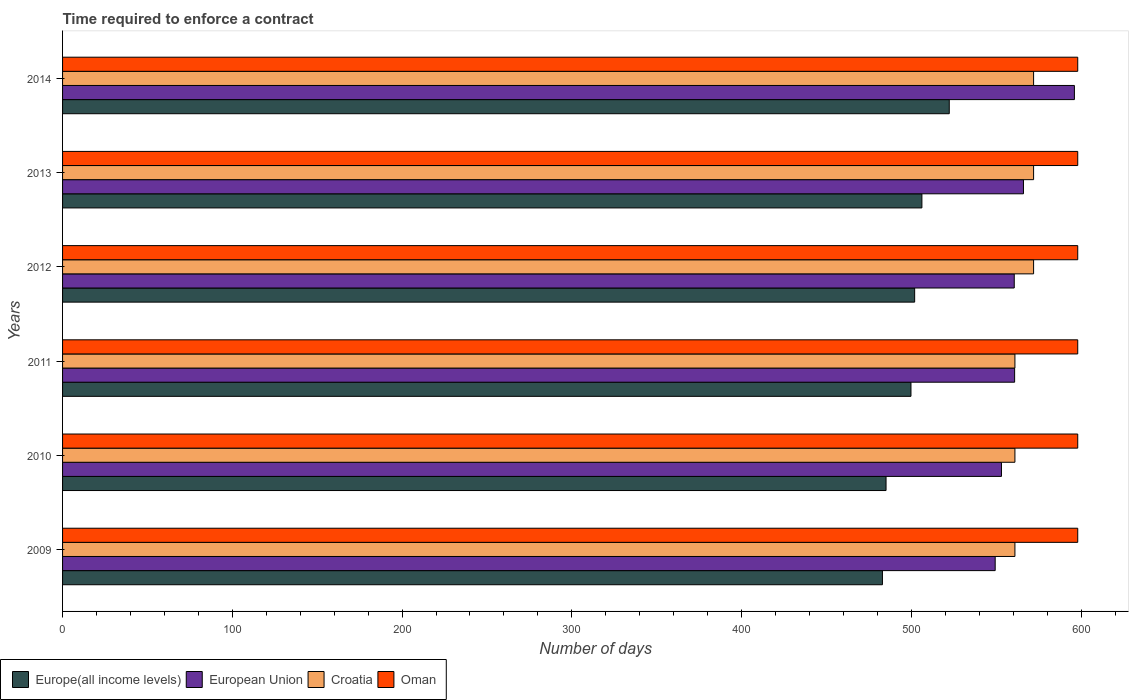How many bars are there on the 1st tick from the bottom?
Provide a succinct answer. 4. What is the label of the 1st group of bars from the top?
Make the answer very short. 2014. In how many cases, is the number of bars for a given year not equal to the number of legend labels?
Provide a short and direct response. 0. What is the number of days required to enforce a contract in Oman in 2011?
Keep it short and to the point. 598. Across all years, what is the maximum number of days required to enforce a contract in Croatia?
Offer a terse response. 572. Across all years, what is the minimum number of days required to enforce a contract in European Union?
Ensure brevity in your answer.  549.37. In which year was the number of days required to enforce a contract in Oman maximum?
Provide a short and direct response. 2009. In which year was the number of days required to enforce a contract in European Union minimum?
Ensure brevity in your answer.  2009. What is the total number of days required to enforce a contract in European Union in the graph?
Make the answer very short. 3385.94. What is the difference between the number of days required to enforce a contract in Oman in 2012 and that in 2013?
Give a very brief answer. 0. What is the difference between the number of days required to enforce a contract in Oman in 2009 and the number of days required to enforce a contract in Europe(all income levels) in 2013?
Give a very brief answer. 91.8. What is the average number of days required to enforce a contract in European Union per year?
Your answer should be compact. 564.32. In the year 2010, what is the difference between the number of days required to enforce a contract in Oman and number of days required to enforce a contract in Europe(all income levels)?
Your answer should be compact. 112.91. What is the ratio of the number of days required to enforce a contract in Europe(all income levels) in 2009 to that in 2011?
Your response must be concise. 0.97. Is the number of days required to enforce a contract in Europe(all income levels) in 2009 less than that in 2014?
Your answer should be very brief. Yes. What is the difference between the highest and the second highest number of days required to enforce a contract in European Union?
Your answer should be compact. 30. What is the difference between the highest and the lowest number of days required to enforce a contract in European Union?
Your response must be concise. 46.67. Is the sum of the number of days required to enforce a contract in Oman in 2011 and 2014 greater than the maximum number of days required to enforce a contract in Europe(all income levels) across all years?
Your response must be concise. Yes. Is it the case that in every year, the sum of the number of days required to enforce a contract in Croatia and number of days required to enforce a contract in European Union is greater than the sum of number of days required to enforce a contract in Europe(all income levels) and number of days required to enforce a contract in Oman?
Keep it short and to the point. Yes. What does the 1st bar from the top in 2010 represents?
Provide a succinct answer. Oman. What does the 1st bar from the bottom in 2012 represents?
Keep it short and to the point. Europe(all income levels). Is it the case that in every year, the sum of the number of days required to enforce a contract in Oman and number of days required to enforce a contract in European Union is greater than the number of days required to enforce a contract in Europe(all income levels)?
Make the answer very short. Yes. Are all the bars in the graph horizontal?
Provide a succinct answer. Yes. What is the difference between two consecutive major ticks on the X-axis?
Your response must be concise. 100. Are the values on the major ticks of X-axis written in scientific E-notation?
Ensure brevity in your answer.  No. Where does the legend appear in the graph?
Keep it short and to the point. Bottom left. How many legend labels are there?
Provide a succinct answer. 4. How are the legend labels stacked?
Offer a very short reply. Horizontal. What is the title of the graph?
Provide a succinct answer. Time required to enforce a contract. Does "France" appear as one of the legend labels in the graph?
Offer a very short reply. No. What is the label or title of the X-axis?
Provide a succinct answer. Number of days. What is the Number of days in Europe(all income levels) in 2009?
Your response must be concise. 482.96. What is the Number of days in European Union in 2009?
Offer a very short reply. 549.37. What is the Number of days in Croatia in 2009?
Your response must be concise. 561. What is the Number of days in Oman in 2009?
Give a very brief answer. 598. What is the Number of days of Europe(all income levels) in 2010?
Keep it short and to the point. 485.09. What is the Number of days in European Union in 2010?
Ensure brevity in your answer.  553.07. What is the Number of days of Croatia in 2010?
Provide a succinct answer. 561. What is the Number of days of Oman in 2010?
Keep it short and to the point. 598. What is the Number of days in Europe(all income levels) in 2011?
Provide a short and direct response. 499.77. What is the Number of days in European Union in 2011?
Make the answer very short. 560.82. What is the Number of days in Croatia in 2011?
Your answer should be compact. 561. What is the Number of days of Oman in 2011?
Give a very brief answer. 598. What is the Number of days in Europe(all income levels) in 2012?
Offer a very short reply. 501.94. What is the Number of days in European Union in 2012?
Offer a very short reply. 560.61. What is the Number of days of Croatia in 2012?
Make the answer very short. 572. What is the Number of days in Oman in 2012?
Your answer should be compact. 598. What is the Number of days in Europe(all income levels) in 2013?
Your answer should be very brief. 506.2. What is the Number of days of European Union in 2013?
Provide a short and direct response. 566.04. What is the Number of days in Croatia in 2013?
Keep it short and to the point. 572. What is the Number of days of Oman in 2013?
Give a very brief answer. 598. What is the Number of days in Europe(all income levels) in 2014?
Provide a short and direct response. 522.33. What is the Number of days of European Union in 2014?
Ensure brevity in your answer.  596.04. What is the Number of days in Croatia in 2014?
Provide a succinct answer. 572. What is the Number of days of Oman in 2014?
Offer a terse response. 598. Across all years, what is the maximum Number of days in Europe(all income levels)?
Give a very brief answer. 522.33. Across all years, what is the maximum Number of days of European Union?
Provide a succinct answer. 596.04. Across all years, what is the maximum Number of days in Croatia?
Make the answer very short. 572. Across all years, what is the maximum Number of days of Oman?
Keep it short and to the point. 598. Across all years, what is the minimum Number of days in Europe(all income levels)?
Provide a short and direct response. 482.96. Across all years, what is the minimum Number of days of European Union?
Offer a terse response. 549.37. Across all years, what is the minimum Number of days of Croatia?
Offer a terse response. 561. Across all years, what is the minimum Number of days of Oman?
Provide a short and direct response. 598. What is the total Number of days in Europe(all income levels) in the graph?
Your answer should be compact. 2998.28. What is the total Number of days of European Union in the graph?
Keep it short and to the point. 3385.94. What is the total Number of days of Croatia in the graph?
Ensure brevity in your answer.  3399. What is the total Number of days of Oman in the graph?
Keep it short and to the point. 3588. What is the difference between the Number of days in Europe(all income levels) in 2009 and that in 2010?
Provide a short and direct response. -2.13. What is the difference between the Number of days of European Union in 2009 and that in 2010?
Offer a very short reply. -3.7. What is the difference between the Number of days in Croatia in 2009 and that in 2010?
Make the answer very short. 0. What is the difference between the Number of days of Europe(all income levels) in 2009 and that in 2011?
Your response must be concise. -16.81. What is the difference between the Number of days of European Union in 2009 and that in 2011?
Offer a terse response. -11.45. What is the difference between the Number of days of Croatia in 2009 and that in 2011?
Provide a short and direct response. 0. What is the difference between the Number of days of Europe(all income levels) in 2009 and that in 2012?
Your answer should be very brief. -18.98. What is the difference between the Number of days of European Union in 2009 and that in 2012?
Make the answer very short. -11.24. What is the difference between the Number of days of Croatia in 2009 and that in 2012?
Ensure brevity in your answer.  -11. What is the difference between the Number of days of Oman in 2009 and that in 2012?
Ensure brevity in your answer.  0. What is the difference between the Number of days in Europe(all income levels) in 2009 and that in 2013?
Provide a short and direct response. -23.25. What is the difference between the Number of days of European Union in 2009 and that in 2013?
Keep it short and to the point. -16.67. What is the difference between the Number of days of Europe(all income levels) in 2009 and that in 2014?
Your response must be concise. -39.37. What is the difference between the Number of days of European Union in 2009 and that in 2014?
Keep it short and to the point. -46.67. What is the difference between the Number of days of Oman in 2009 and that in 2014?
Give a very brief answer. 0. What is the difference between the Number of days of Europe(all income levels) in 2010 and that in 2011?
Offer a very short reply. -14.68. What is the difference between the Number of days of European Union in 2010 and that in 2011?
Give a very brief answer. -7.75. What is the difference between the Number of days in Oman in 2010 and that in 2011?
Your answer should be compact. 0. What is the difference between the Number of days of Europe(all income levels) in 2010 and that in 2012?
Ensure brevity in your answer.  -16.85. What is the difference between the Number of days in European Union in 2010 and that in 2012?
Ensure brevity in your answer.  -7.53. What is the difference between the Number of days of Europe(all income levels) in 2010 and that in 2013?
Give a very brief answer. -21.12. What is the difference between the Number of days of European Union in 2010 and that in 2013?
Make the answer very short. -12.96. What is the difference between the Number of days of Europe(all income levels) in 2010 and that in 2014?
Your answer should be very brief. -37.24. What is the difference between the Number of days of European Union in 2010 and that in 2014?
Your answer should be very brief. -42.96. What is the difference between the Number of days of Croatia in 2010 and that in 2014?
Provide a short and direct response. -11. What is the difference between the Number of days of Europe(all income levels) in 2011 and that in 2012?
Your answer should be compact. -2.17. What is the difference between the Number of days of European Union in 2011 and that in 2012?
Provide a succinct answer. 0.21. What is the difference between the Number of days in Croatia in 2011 and that in 2012?
Your answer should be very brief. -11. What is the difference between the Number of days in Oman in 2011 and that in 2012?
Give a very brief answer. 0. What is the difference between the Number of days in Europe(all income levels) in 2011 and that in 2013?
Ensure brevity in your answer.  -6.44. What is the difference between the Number of days in European Union in 2011 and that in 2013?
Give a very brief answer. -5.21. What is the difference between the Number of days of Croatia in 2011 and that in 2013?
Your answer should be compact. -11. What is the difference between the Number of days of Oman in 2011 and that in 2013?
Your answer should be very brief. 0. What is the difference between the Number of days in Europe(all income levels) in 2011 and that in 2014?
Provide a short and direct response. -22.56. What is the difference between the Number of days of European Union in 2011 and that in 2014?
Your answer should be very brief. -35.21. What is the difference between the Number of days in Oman in 2011 and that in 2014?
Ensure brevity in your answer.  0. What is the difference between the Number of days of Europe(all income levels) in 2012 and that in 2013?
Offer a very short reply. -4.27. What is the difference between the Number of days of European Union in 2012 and that in 2013?
Give a very brief answer. -5.43. What is the difference between the Number of days of Croatia in 2012 and that in 2013?
Provide a short and direct response. 0. What is the difference between the Number of days in Europe(all income levels) in 2012 and that in 2014?
Offer a terse response. -20.39. What is the difference between the Number of days in European Union in 2012 and that in 2014?
Ensure brevity in your answer.  -35.43. What is the difference between the Number of days of Europe(all income levels) in 2013 and that in 2014?
Make the answer very short. -16.12. What is the difference between the Number of days of Croatia in 2013 and that in 2014?
Keep it short and to the point. 0. What is the difference between the Number of days in Oman in 2013 and that in 2014?
Your answer should be compact. 0. What is the difference between the Number of days of Europe(all income levels) in 2009 and the Number of days of European Union in 2010?
Provide a succinct answer. -70.12. What is the difference between the Number of days in Europe(all income levels) in 2009 and the Number of days in Croatia in 2010?
Offer a very short reply. -78.04. What is the difference between the Number of days in Europe(all income levels) in 2009 and the Number of days in Oman in 2010?
Give a very brief answer. -115.04. What is the difference between the Number of days of European Union in 2009 and the Number of days of Croatia in 2010?
Offer a terse response. -11.63. What is the difference between the Number of days in European Union in 2009 and the Number of days in Oman in 2010?
Keep it short and to the point. -48.63. What is the difference between the Number of days in Croatia in 2009 and the Number of days in Oman in 2010?
Provide a short and direct response. -37. What is the difference between the Number of days in Europe(all income levels) in 2009 and the Number of days in European Union in 2011?
Provide a short and direct response. -77.86. What is the difference between the Number of days of Europe(all income levels) in 2009 and the Number of days of Croatia in 2011?
Provide a short and direct response. -78.04. What is the difference between the Number of days of Europe(all income levels) in 2009 and the Number of days of Oman in 2011?
Your response must be concise. -115.04. What is the difference between the Number of days of European Union in 2009 and the Number of days of Croatia in 2011?
Offer a terse response. -11.63. What is the difference between the Number of days in European Union in 2009 and the Number of days in Oman in 2011?
Provide a short and direct response. -48.63. What is the difference between the Number of days of Croatia in 2009 and the Number of days of Oman in 2011?
Your response must be concise. -37. What is the difference between the Number of days of Europe(all income levels) in 2009 and the Number of days of European Union in 2012?
Provide a short and direct response. -77.65. What is the difference between the Number of days of Europe(all income levels) in 2009 and the Number of days of Croatia in 2012?
Keep it short and to the point. -89.04. What is the difference between the Number of days of Europe(all income levels) in 2009 and the Number of days of Oman in 2012?
Your answer should be very brief. -115.04. What is the difference between the Number of days in European Union in 2009 and the Number of days in Croatia in 2012?
Offer a very short reply. -22.63. What is the difference between the Number of days of European Union in 2009 and the Number of days of Oman in 2012?
Your response must be concise. -48.63. What is the difference between the Number of days in Croatia in 2009 and the Number of days in Oman in 2012?
Offer a terse response. -37. What is the difference between the Number of days of Europe(all income levels) in 2009 and the Number of days of European Union in 2013?
Provide a succinct answer. -83.08. What is the difference between the Number of days of Europe(all income levels) in 2009 and the Number of days of Croatia in 2013?
Your answer should be very brief. -89.04. What is the difference between the Number of days in Europe(all income levels) in 2009 and the Number of days in Oman in 2013?
Your response must be concise. -115.04. What is the difference between the Number of days of European Union in 2009 and the Number of days of Croatia in 2013?
Provide a short and direct response. -22.63. What is the difference between the Number of days in European Union in 2009 and the Number of days in Oman in 2013?
Offer a terse response. -48.63. What is the difference between the Number of days of Croatia in 2009 and the Number of days of Oman in 2013?
Provide a short and direct response. -37. What is the difference between the Number of days of Europe(all income levels) in 2009 and the Number of days of European Union in 2014?
Keep it short and to the point. -113.08. What is the difference between the Number of days of Europe(all income levels) in 2009 and the Number of days of Croatia in 2014?
Your response must be concise. -89.04. What is the difference between the Number of days in Europe(all income levels) in 2009 and the Number of days in Oman in 2014?
Offer a terse response. -115.04. What is the difference between the Number of days of European Union in 2009 and the Number of days of Croatia in 2014?
Your answer should be compact. -22.63. What is the difference between the Number of days of European Union in 2009 and the Number of days of Oman in 2014?
Provide a short and direct response. -48.63. What is the difference between the Number of days of Croatia in 2009 and the Number of days of Oman in 2014?
Offer a terse response. -37. What is the difference between the Number of days of Europe(all income levels) in 2010 and the Number of days of European Union in 2011?
Your response must be concise. -75.74. What is the difference between the Number of days of Europe(all income levels) in 2010 and the Number of days of Croatia in 2011?
Keep it short and to the point. -75.91. What is the difference between the Number of days in Europe(all income levels) in 2010 and the Number of days in Oman in 2011?
Your answer should be very brief. -112.91. What is the difference between the Number of days in European Union in 2010 and the Number of days in Croatia in 2011?
Your answer should be very brief. -7.93. What is the difference between the Number of days in European Union in 2010 and the Number of days in Oman in 2011?
Ensure brevity in your answer.  -44.93. What is the difference between the Number of days in Croatia in 2010 and the Number of days in Oman in 2011?
Ensure brevity in your answer.  -37. What is the difference between the Number of days of Europe(all income levels) in 2010 and the Number of days of European Union in 2012?
Make the answer very short. -75.52. What is the difference between the Number of days in Europe(all income levels) in 2010 and the Number of days in Croatia in 2012?
Offer a very short reply. -86.91. What is the difference between the Number of days in Europe(all income levels) in 2010 and the Number of days in Oman in 2012?
Give a very brief answer. -112.91. What is the difference between the Number of days of European Union in 2010 and the Number of days of Croatia in 2012?
Your answer should be very brief. -18.93. What is the difference between the Number of days in European Union in 2010 and the Number of days in Oman in 2012?
Your answer should be compact. -44.93. What is the difference between the Number of days of Croatia in 2010 and the Number of days of Oman in 2012?
Make the answer very short. -37. What is the difference between the Number of days of Europe(all income levels) in 2010 and the Number of days of European Union in 2013?
Your answer should be compact. -80.95. What is the difference between the Number of days of Europe(all income levels) in 2010 and the Number of days of Croatia in 2013?
Offer a very short reply. -86.91. What is the difference between the Number of days in Europe(all income levels) in 2010 and the Number of days in Oman in 2013?
Provide a short and direct response. -112.91. What is the difference between the Number of days in European Union in 2010 and the Number of days in Croatia in 2013?
Offer a very short reply. -18.93. What is the difference between the Number of days in European Union in 2010 and the Number of days in Oman in 2013?
Make the answer very short. -44.93. What is the difference between the Number of days of Croatia in 2010 and the Number of days of Oman in 2013?
Ensure brevity in your answer.  -37. What is the difference between the Number of days of Europe(all income levels) in 2010 and the Number of days of European Union in 2014?
Offer a terse response. -110.95. What is the difference between the Number of days in Europe(all income levels) in 2010 and the Number of days in Croatia in 2014?
Offer a terse response. -86.91. What is the difference between the Number of days of Europe(all income levels) in 2010 and the Number of days of Oman in 2014?
Your answer should be very brief. -112.91. What is the difference between the Number of days in European Union in 2010 and the Number of days in Croatia in 2014?
Provide a short and direct response. -18.93. What is the difference between the Number of days of European Union in 2010 and the Number of days of Oman in 2014?
Make the answer very short. -44.93. What is the difference between the Number of days of Croatia in 2010 and the Number of days of Oman in 2014?
Keep it short and to the point. -37. What is the difference between the Number of days in Europe(all income levels) in 2011 and the Number of days in European Union in 2012?
Provide a succinct answer. -60.84. What is the difference between the Number of days in Europe(all income levels) in 2011 and the Number of days in Croatia in 2012?
Your answer should be very brief. -72.23. What is the difference between the Number of days in Europe(all income levels) in 2011 and the Number of days in Oman in 2012?
Your answer should be very brief. -98.23. What is the difference between the Number of days of European Union in 2011 and the Number of days of Croatia in 2012?
Make the answer very short. -11.18. What is the difference between the Number of days in European Union in 2011 and the Number of days in Oman in 2012?
Give a very brief answer. -37.18. What is the difference between the Number of days of Croatia in 2011 and the Number of days of Oman in 2012?
Make the answer very short. -37. What is the difference between the Number of days of Europe(all income levels) in 2011 and the Number of days of European Union in 2013?
Your answer should be very brief. -66.27. What is the difference between the Number of days of Europe(all income levels) in 2011 and the Number of days of Croatia in 2013?
Offer a very short reply. -72.23. What is the difference between the Number of days of Europe(all income levels) in 2011 and the Number of days of Oman in 2013?
Offer a very short reply. -98.23. What is the difference between the Number of days of European Union in 2011 and the Number of days of Croatia in 2013?
Ensure brevity in your answer.  -11.18. What is the difference between the Number of days in European Union in 2011 and the Number of days in Oman in 2013?
Keep it short and to the point. -37.18. What is the difference between the Number of days in Croatia in 2011 and the Number of days in Oman in 2013?
Offer a very short reply. -37. What is the difference between the Number of days in Europe(all income levels) in 2011 and the Number of days in European Union in 2014?
Make the answer very short. -96.27. What is the difference between the Number of days of Europe(all income levels) in 2011 and the Number of days of Croatia in 2014?
Provide a short and direct response. -72.23. What is the difference between the Number of days in Europe(all income levels) in 2011 and the Number of days in Oman in 2014?
Give a very brief answer. -98.23. What is the difference between the Number of days in European Union in 2011 and the Number of days in Croatia in 2014?
Offer a terse response. -11.18. What is the difference between the Number of days of European Union in 2011 and the Number of days of Oman in 2014?
Keep it short and to the point. -37.18. What is the difference between the Number of days of Croatia in 2011 and the Number of days of Oman in 2014?
Your answer should be compact. -37. What is the difference between the Number of days of Europe(all income levels) in 2012 and the Number of days of European Union in 2013?
Provide a short and direct response. -64.1. What is the difference between the Number of days in Europe(all income levels) in 2012 and the Number of days in Croatia in 2013?
Offer a very short reply. -70.06. What is the difference between the Number of days of Europe(all income levels) in 2012 and the Number of days of Oman in 2013?
Offer a terse response. -96.06. What is the difference between the Number of days in European Union in 2012 and the Number of days in Croatia in 2013?
Your answer should be compact. -11.39. What is the difference between the Number of days of European Union in 2012 and the Number of days of Oman in 2013?
Make the answer very short. -37.39. What is the difference between the Number of days in Europe(all income levels) in 2012 and the Number of days in European Union in 2014?
Provide a succinct answer. -94.1. What is the difference between the Number of days of Europe(all income levels) in 2012 and the Number of days of Croatia in 2014?
Your answer should be compact. -70.06. What is the difference between the Number of days in Europe(all income levels) in 2012 and the Number of days in Oman in 2014?
Give a very brief answer. -96.06. What is the difference between the Number of days of European Union in 2012 and the Number of days of Croatia in 2014?
Offer a terse response. -11.39. What is the difference between the Number of days in European Union in 2012 and the Number of days in Oman in 2014?
Offer a terse response. -37.39. What is the difference between the Number of days of Europe(all income levels) in 2013 and the Number of days of European Union in 2014?
Ensure brevity in your answer.  -89.83. What is the difference between the Number of days in Europe(all income levels) in 2013 and the Number of days in Croatia in 2014?
Give a very brief answer. -65.8. What is the difference between the Number of days in Europe(all income levels) in 2013 and the Number of days in Oman in 2014?
Give a very brief answer. -91.8. What is the difference between the Number of days of European Union in 2013 and the Number of days of Croatia in 2014?
Your answer should be very brief. -5.96. What is the difference between the Number of days of European Union in 2013 and the Number of days of Oman in 2014?
Offer a very short reply. -31.96. What is the average Number of days of Europe(all income levels) per year?
Offer a terse response. 499.71. What is the average Number of days of European Union per year?
Make the answer very short. 564.32. What is the average Number of days in Croatia per year?
Keep it short and to the point. 566.5. What is the average Number of days in Oman per year?
Keep it short and to the point. 598. In the year 2009, what is the difference between the Number of days of Europe(all income levels) and Number of days of European Union?
Provide a succinct answer. -66.41. In the year 2009, what is the difference between the Number of days of Europe(all income levels) and Number of days of Croatia?
Provide a short and direct response. -78.04. In the year 2009, what is the difference between the Number of days of Europe(all income levels) and Number of days of Oman?
Make the answer very short. -115.04. In the year 2009, what is the difference between the Number of days of European Union and Number of days of Croatia?
Offer a very short reply. -11.63. In the year 2009, what is the difference between the Number of days of European Union and Number of days of Oman?
Keep it short and to the point. -48.63. In the year 2009, what is the difference between the Number of days in Croatia and Number of days in Oman?
Ensure brevity in your answer.  -37. In the year 2010, what is the difference between the Number of days in Europe(all income levels) and Number of days in European Union?
Your response must be concise. -67.99. In the year 2010, what is the difference between the Number of days of Europe(all income levels) and Number of days of Croatia?
Offer a terse response. -75.91. In the year 2010, what is the difference between the Number of days of Europe(all income levels) and Number of days of Oman?
Provide a short and direct response. -112.91. In the year 2010, what is the difference between the Number of days in European Union and Number of days in Croatia?
Offer a very short reply. -7.93. In the year 2010, what is the difference between the Number of days of European Union and Number of days of Oman?
Provide a short and direct response. -44.93. In the year 2010, what is the difference between the Number of days of Croatia and Number of days of Oman?
Your answer should be compact. -37. In the year 2011, what is the difference between the Number of days of Europe(all income levels) and Number of days of European Union?
Provide a short and direct response. -61.06. In the year 2011, what is the difference between the Number of days of Europe(all income levels) and Number of days of Croatia?
Your answer should be very brief. -61.23. In the year 2011, what is the difference between the Number of days of Europe(all income levels) and Number of days of Oman?
Give a very brief answer. -98.23. In the year 2011, what is the difference between the Number of days of European Union and Number of days of Croatia?
Your answer should be very brief. -0.18. In the year 2011, what is the difference between the Number of days of European Union and Number of days of Oman?
Offer a very short reply. -37.18. In the year 2011, what is the difference between the Number of days in Croatia and Number of days in Oman?
Offer a very short reply. -37. In the year 2012, what is the difference between the Number of days in Europe(all income levels) and Number of days in European Union?
Your answer should be very brief. -58.67. In the year 2012, what is the difference between the Number of days of Europe(all income levels) and Number of days of Croatia?
Offer a very short reply. -70.06. In the year 2012, what is the difference between the Number of days in Europe(all income levels) and Number of days in Oman?
Make the answer very short. -96.06. In the year 2012, what is the difference between the Number of days of European Union and Number of days of Croatia?
Provide a succinct answer. -11.39. In the year 2012, what is the difference between the Number of days of European Union and Number of days of Oman?
Keep it short and to the point. -37.39. In the year 2013, what is the difference between the Number of days of Europe(all income levels) and Number of days of European Union?
Make the answer very short. -59.83. In the year 2013, what is the difference between the Number of days in Europe(all income levels) and Number of days in Croatia?
Make the answer very short. -65.8. In the year 2013, what is the difference between the Number of days in Europe(all income levels) and Number of days in Oman?
Provide a short and direct response. -91.8. In the year 2013, what is the difference between the Number of days of European Union and Number of days of Croatia?
Provide a succinct answer. -5.96. In the year 2013, what is the difference between the Number of days in European Union and Number of days in Oman?
Your answer should be compact. -31.96. In the year 2013, what is the difference between the Number of days in Croatia and Number of days in Oman?
Give a very brief answer. -26. In the year 2014, what is the difference between the Number of days of Europe(all income levels) and Number of days of European Union?
Keep it short and to the point. -73.71. In the year 2014, what is the difference between the Number of days in Europe(all income levels) and Number of days in Croatia?
Offer a very short reply. -49.67. In the year 2014, what is the difference between the Number of days in Europe(all income levels) and Number of days in Oman?
Provide a succinct answer. -75.67. In the year 2014, what is the difference between the Number of days of European Union and Number of days of Croatia?
Offer a terse response. 24.04. In the year 2014, what is the difference between the Number of days in European Union and Number of days in Oman?
Make the answer very short. -1.96. In the year 2014, what is the difference between the Number of days of Croatia and Number of days of Oman?
Your answer should be very brief. -26. What is the ratio of the Number of days in Oman in 2009 to that in 2010?
Give a very brief answer. 1. What is the ratio of the Number of days in Europe(all income levels) in 2009 to that in 2011?
Make the answer very short. 0.97. What is the ratio of the Number of days of European Union in 2009 to that in 2011?
Your answer should be very brief. 0.98. What is the ratio of the Number of days of Europe(all income levels) in 2009 to that in 2012?
Keep it short and to the point. 0.96. What is the ratio of the Number of days in European Union in 2009 to that in 2012?
Provide a short and direct response. 0.98. What is the ratio of the Number of days of Croatia in 2009 to that in 2012?
Offer a very short reply. 0.98. What is the ratio of the Number of days of Europe(all income levels) in 2009 to that in 2013?
Give a very brief answer. 0.95. What is the ratio of the Number of days in European Union in 2009 to that in 2013?
Offer a very short reply. 0.97. What is the ratio of the Number of days in Croatia in 2009 to that in 2013?
Ensure brevity in your answer.  0.98. What is the ratio of the Number of days of Oman in 2009 to that in 2013?
Offer a terse response. 1. What is the ratio of the Number of days in Europe(all income levels) in 2009 to that in 2014?
Offer a very short reply. 0.92. What is the ratio of the Number of days in European Union in 2009 to that in 2014?
Offer a very short reply. 0.92. What is the ratio of the Number of days in Croatia in 2009 to that in 2014?
Give a very brief answer. 0.98. What is the ratio of the Number of days in Europe(all income levels) in 2010 to that in 2011?
Offer a terse response. 0.97. What is the ratio of the Number of days of European Union in 2010 to that in 2011?
Your answer should be compact. 0.99. What is the ratio of the Number of days of Europe(all income levels) in 2010 to that in 2012?
Your answer should be very brief. 0.97. What is the ratio of the Number of days in European Union in 2010 to that in 2012?
Provide a succinct answer. 0.99. What is the ratio of the Number of days in Croatia in 2010 to that in 2012?
Give a very brief answer. 0.98. What is the ratio of the Number of days in Oman in 2010 to that in 2012?
Offer a very short reply. 1. What is the ratio of the Number of days in European Union in 2010 to that in 2013?
Offer a terse response. 0.98. What is the ratio of the Number of days in Croatia in 2010 to that in 2013?
Ensure brevity in your answer.  0.98. What is the ratio of the Number of days of Oman in 2010 to that in 2013?
Your answer should be compact. 1. What is the ratio of the Number of days of Europe(all income levels) in 2010 to that in 2014?
Make the answer very short. 0.93. What is the ratio of the Number of days in European Union in 2010 to that in 2014?
Ensure brevity in your answer.  0.93. What is the ratio of the Number of days of Croatia in 2010 to that in 2014?
Offer a terse response. 0.98. What is the ratio of the Number of days in Oman in 2010 to that in 2014?
Your response must be concise. 1. What is the ratio of the Number of days of Europe(all income levels) in 2011 to that in 2012?
Offer a terse response. 1. What is the ratio of the Number of days of Croatia in 2011 to that in 2012?
Make the answer very short. 0.98. What is the ratio of the Number of days in Europe(all income levels) in 2011 to that in 2013?
Your answer should be very brief. 0.99. What is the ratio of the Number of days in European Union in 2011 to that in 2013?
Offer a very short reply. 0.99. What is the ratio of the Number of days of Croatia in 2011 to that in 2013?
Offer a terse response. 0.98. What is the ratio of the Number of days in Europe(all income levels) in 2011 to that in 2014?
Provide a short and direct response. 0.96. What is the ratio of the Number of days of European Union in 2011 to that in 2014?
Your response must be concise. 0.94. What is the ratio of the Number of days of Croatia in 2011 to that in 2014?
Your answer should be compact. 0.98. What is the ratio of the Number of days of Oman in 2011 to that in 2014?
Keep it short and to the point. 1. What is the ratio of the Number of days in Oman in 2012 to that in 2013?
Keep it short and to the point. 1. What is the ratio of the Number of days in Europe(all income levels) in 2012 to that in 2014?
Your answer should be very brief. 0.96. What is the ratio of the Number of days of European Union in 2012 to that in 2014?
Keep it short and to the point. 0.94. What is the ratio of the Number of days in Oman in 2012 to that in 2014?
Ensure brevity in your answer.  1. What is the ratio of the Number of days in Europe(all income levels) in 2013 to that in 2014?
Offer a terse response. 0.97. What is the ratio of the Number of days in European Union in 2013 to that in 2014?
Offer a very short reply. 0.95. What is the difference between the highest and the second highest Number of days of Europe(all income levels)?
Offer a terse response. 16.12. What is the difference between the highest and the second highest Number of days of European Union?
Offer a very short reply. 30. What is the difference between the highest and the second highest Number of days in Croatia?
Offer a very short reply. 0. What is the difference between the highest and the second highest Number of days in Oman?
Your answer should be very brief. 0. What is the difference between the highest and the lowest Number of days in Europe(all income levels)?
Give a very brief answer. 39.37. What is the difference between the highest and the lowest Number of days of European Union?
Give a very brief answer. 46.67. What is the difference between the highest and the lowest Number of days of Croatia?
Ensure brevity in your answer.  11. 